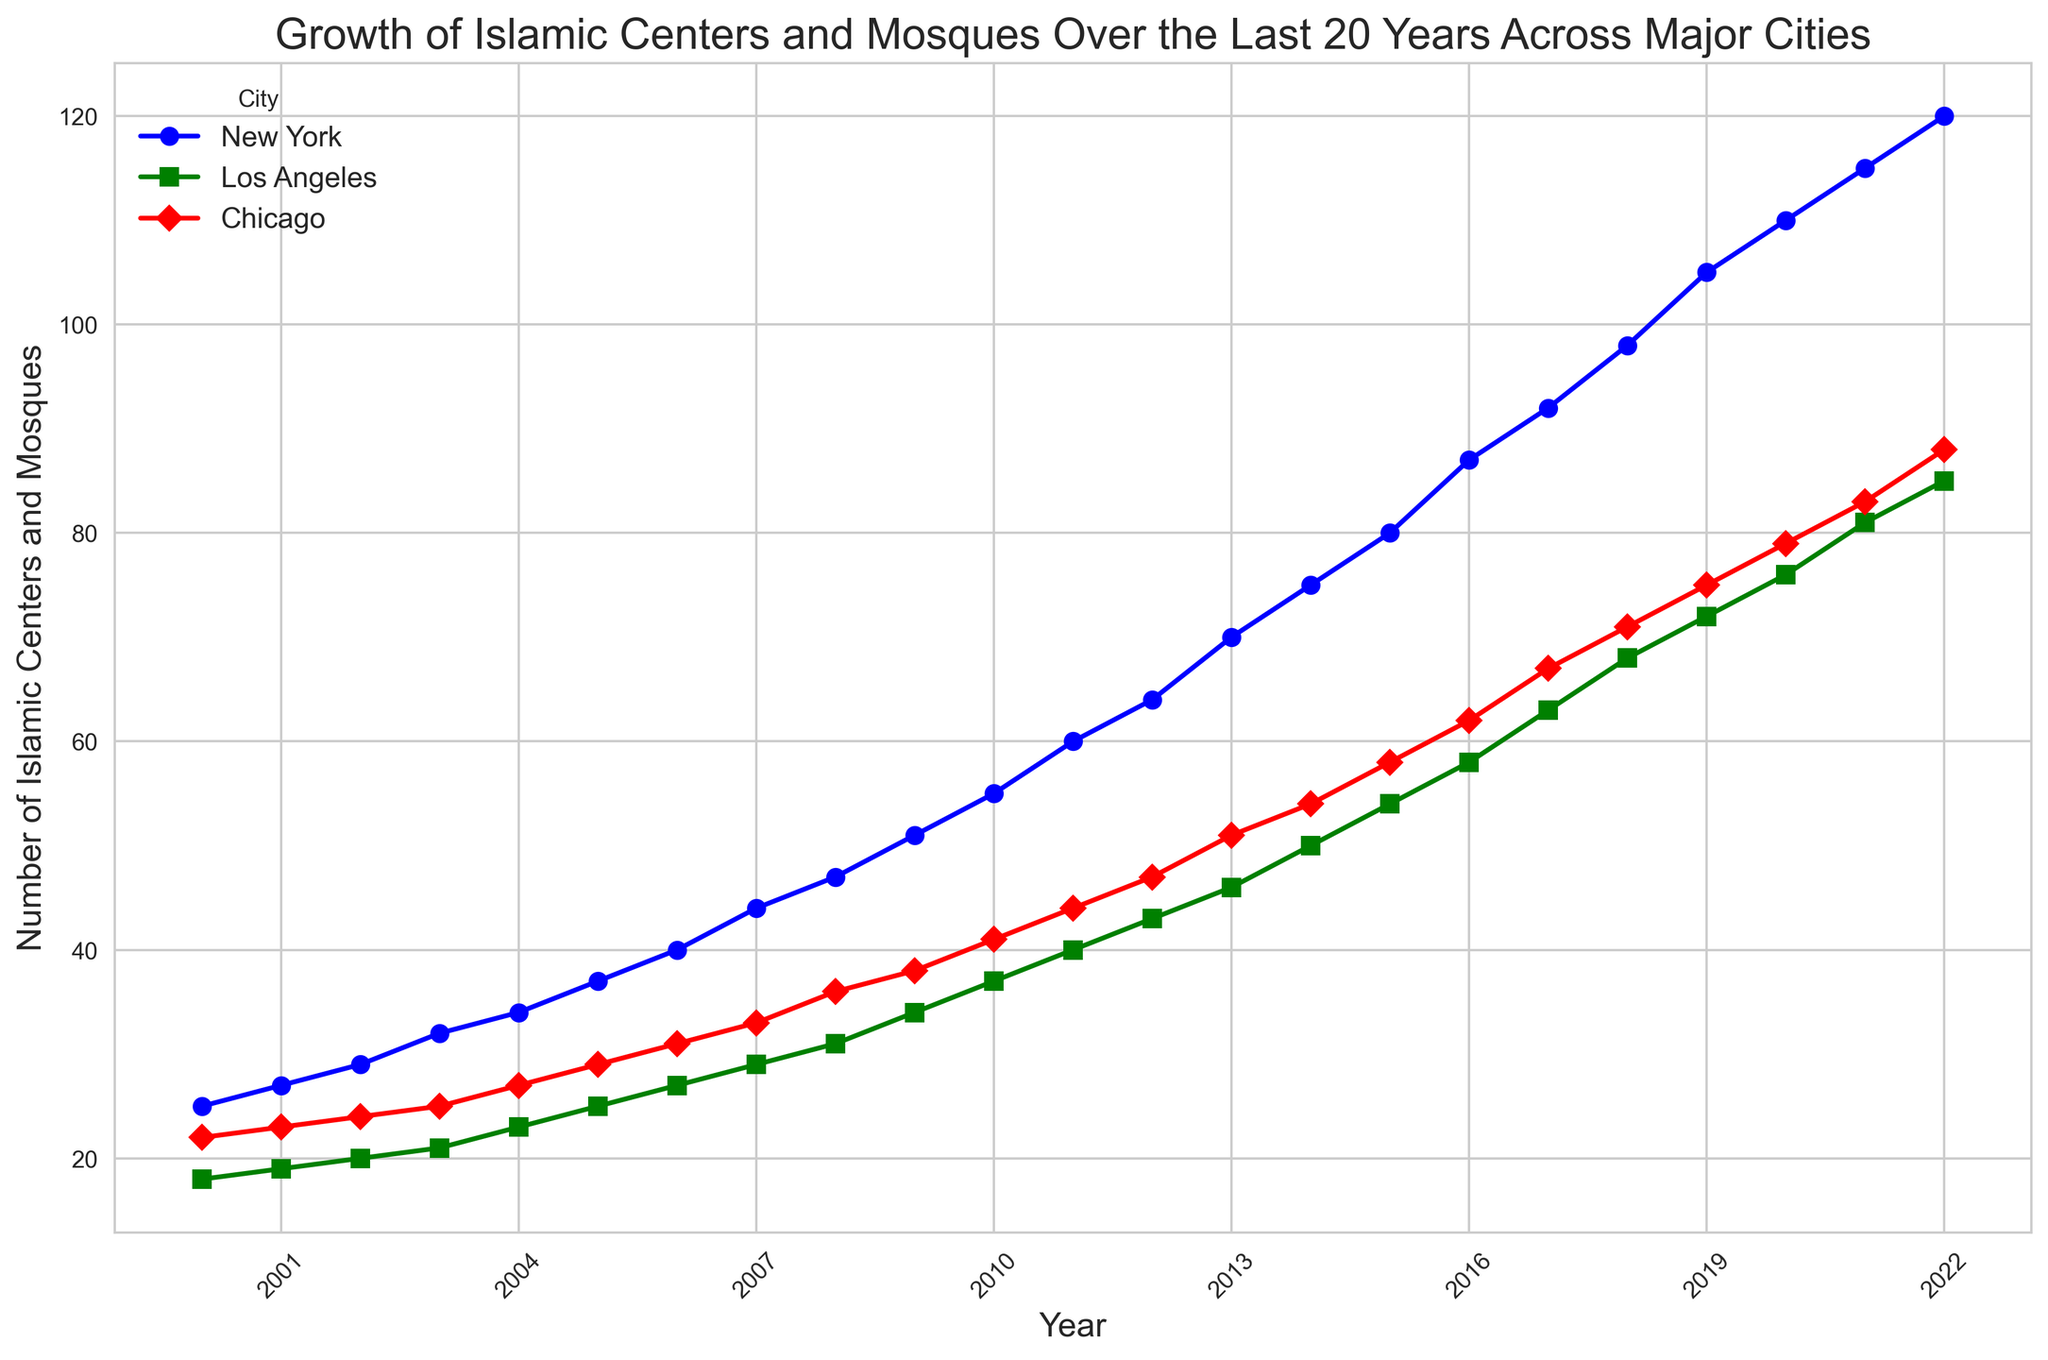Which city had the highest number of Islamic Centers and Mosques in 2022? Check the endpoints of each line on the right side of the figure. The highest endpoint corresponds to the city with the most Islamic Centers and Mosques in 2022.
Answer: New York How many more Islamic Centers and Mosques were there in Chicago in 2022 compared to 2000? Find the values of Chicago in 2022 and 2000, then subtract the 2000 value from the 2022 value. For 2022 it is 88 and for 2000 it is 22. So, 88 - 22 = 66.
Answer: 66 Which city shows the greatest growth in the number of Islamic Centers and Mosques between 2000 and 2022? Compare the increase in values from 2000 to 2022 for each city. New York starts with 25 in 2000 and has 120 in 2022, yielding an increase of 95 which is higher than other cities.
Answer: New York Did Los Angeles ever exceed the number of Islamic Centers and Mosques in New York in any year between 2000 and 2022? Compare the lines for Los Angeles and New York throughout the years. The Los Angeles line never goes above the New York line.
Answer: No In which year did Chicago reach 50 Islamic Centers and Mosques? Look at the point where Chicago's line intersects the value of 50 on the y-axis. This happens in 2013.
Answer: 2013 By how many Islamic Centers and Mosques did New York outnumber Los Angeles in 2011? Determine the values for both cities in 2011: New York had 60, and Los Angeles had 40. The difference is 60 - 40 = 20.
Answer: 20 Which color represents the city of Chicago in the figure? Identify the color of the line that corresponds to Chicago by comparing the lines with the legend. Chicago is represented by the red color.
Answer: Red How many years did it take for Los Angeles to double its number of Islamic Centers and Mosques starting from 2000? Starting with 18 in 2000, doubling would mean reaching 36. Los Angeles first reaches or exceeds this number in 2009. So, it took 9 years from 2000 to 2009.
Answer: 9 years Which city had the slowest growth rate in the number of Islamic Centers and Mosques between 2000 and 2010? Calculate the growth for each city from 2000 to 2010. New York increased by 30, Los Angeles by 19, and Chicago by 19. Since Los Angeles and Chicago both increased by the same value, they are tied for the slowest growth rate.
Answer: Los Angeles and Chicago 